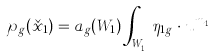<formula> <loc_0><loc_0><loc_500><loc_500>\wp _ { g } ( \check { x } _ { 1 } ) = a _ { g } ( W _ { 1 } ) \int _ { W _ { 1 } ^ { g } } \eta _ { 1 g } \cdot u ^ { m _ { 1 g } }</formula> 